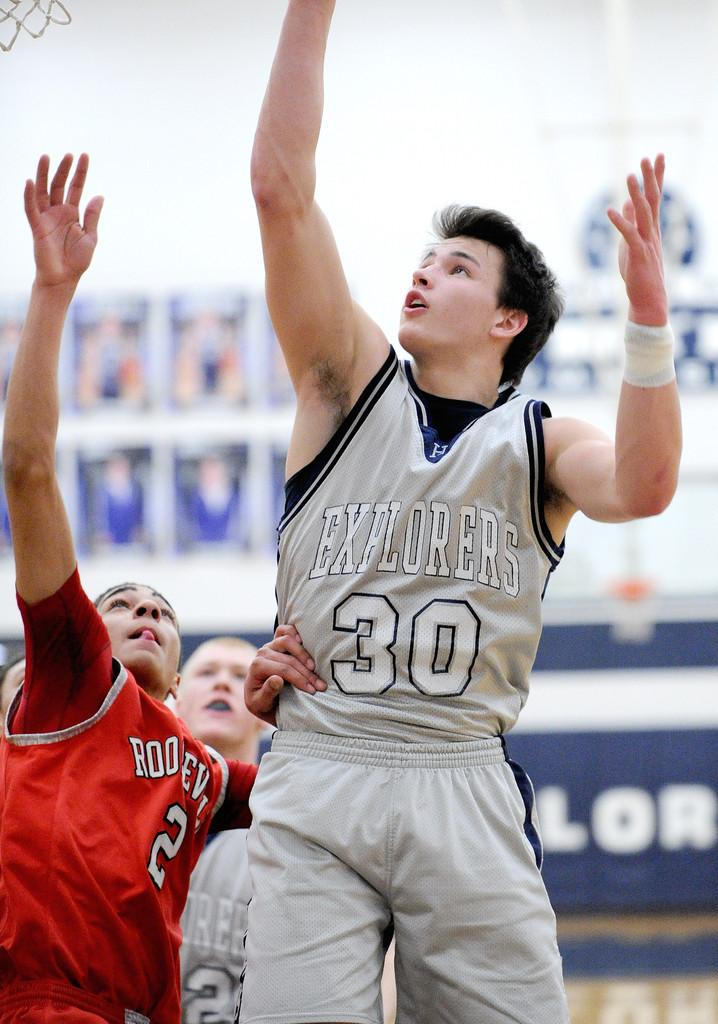<image>
Describe the image concisely. Basketball players with uniform of gray and the number 30 on it. 